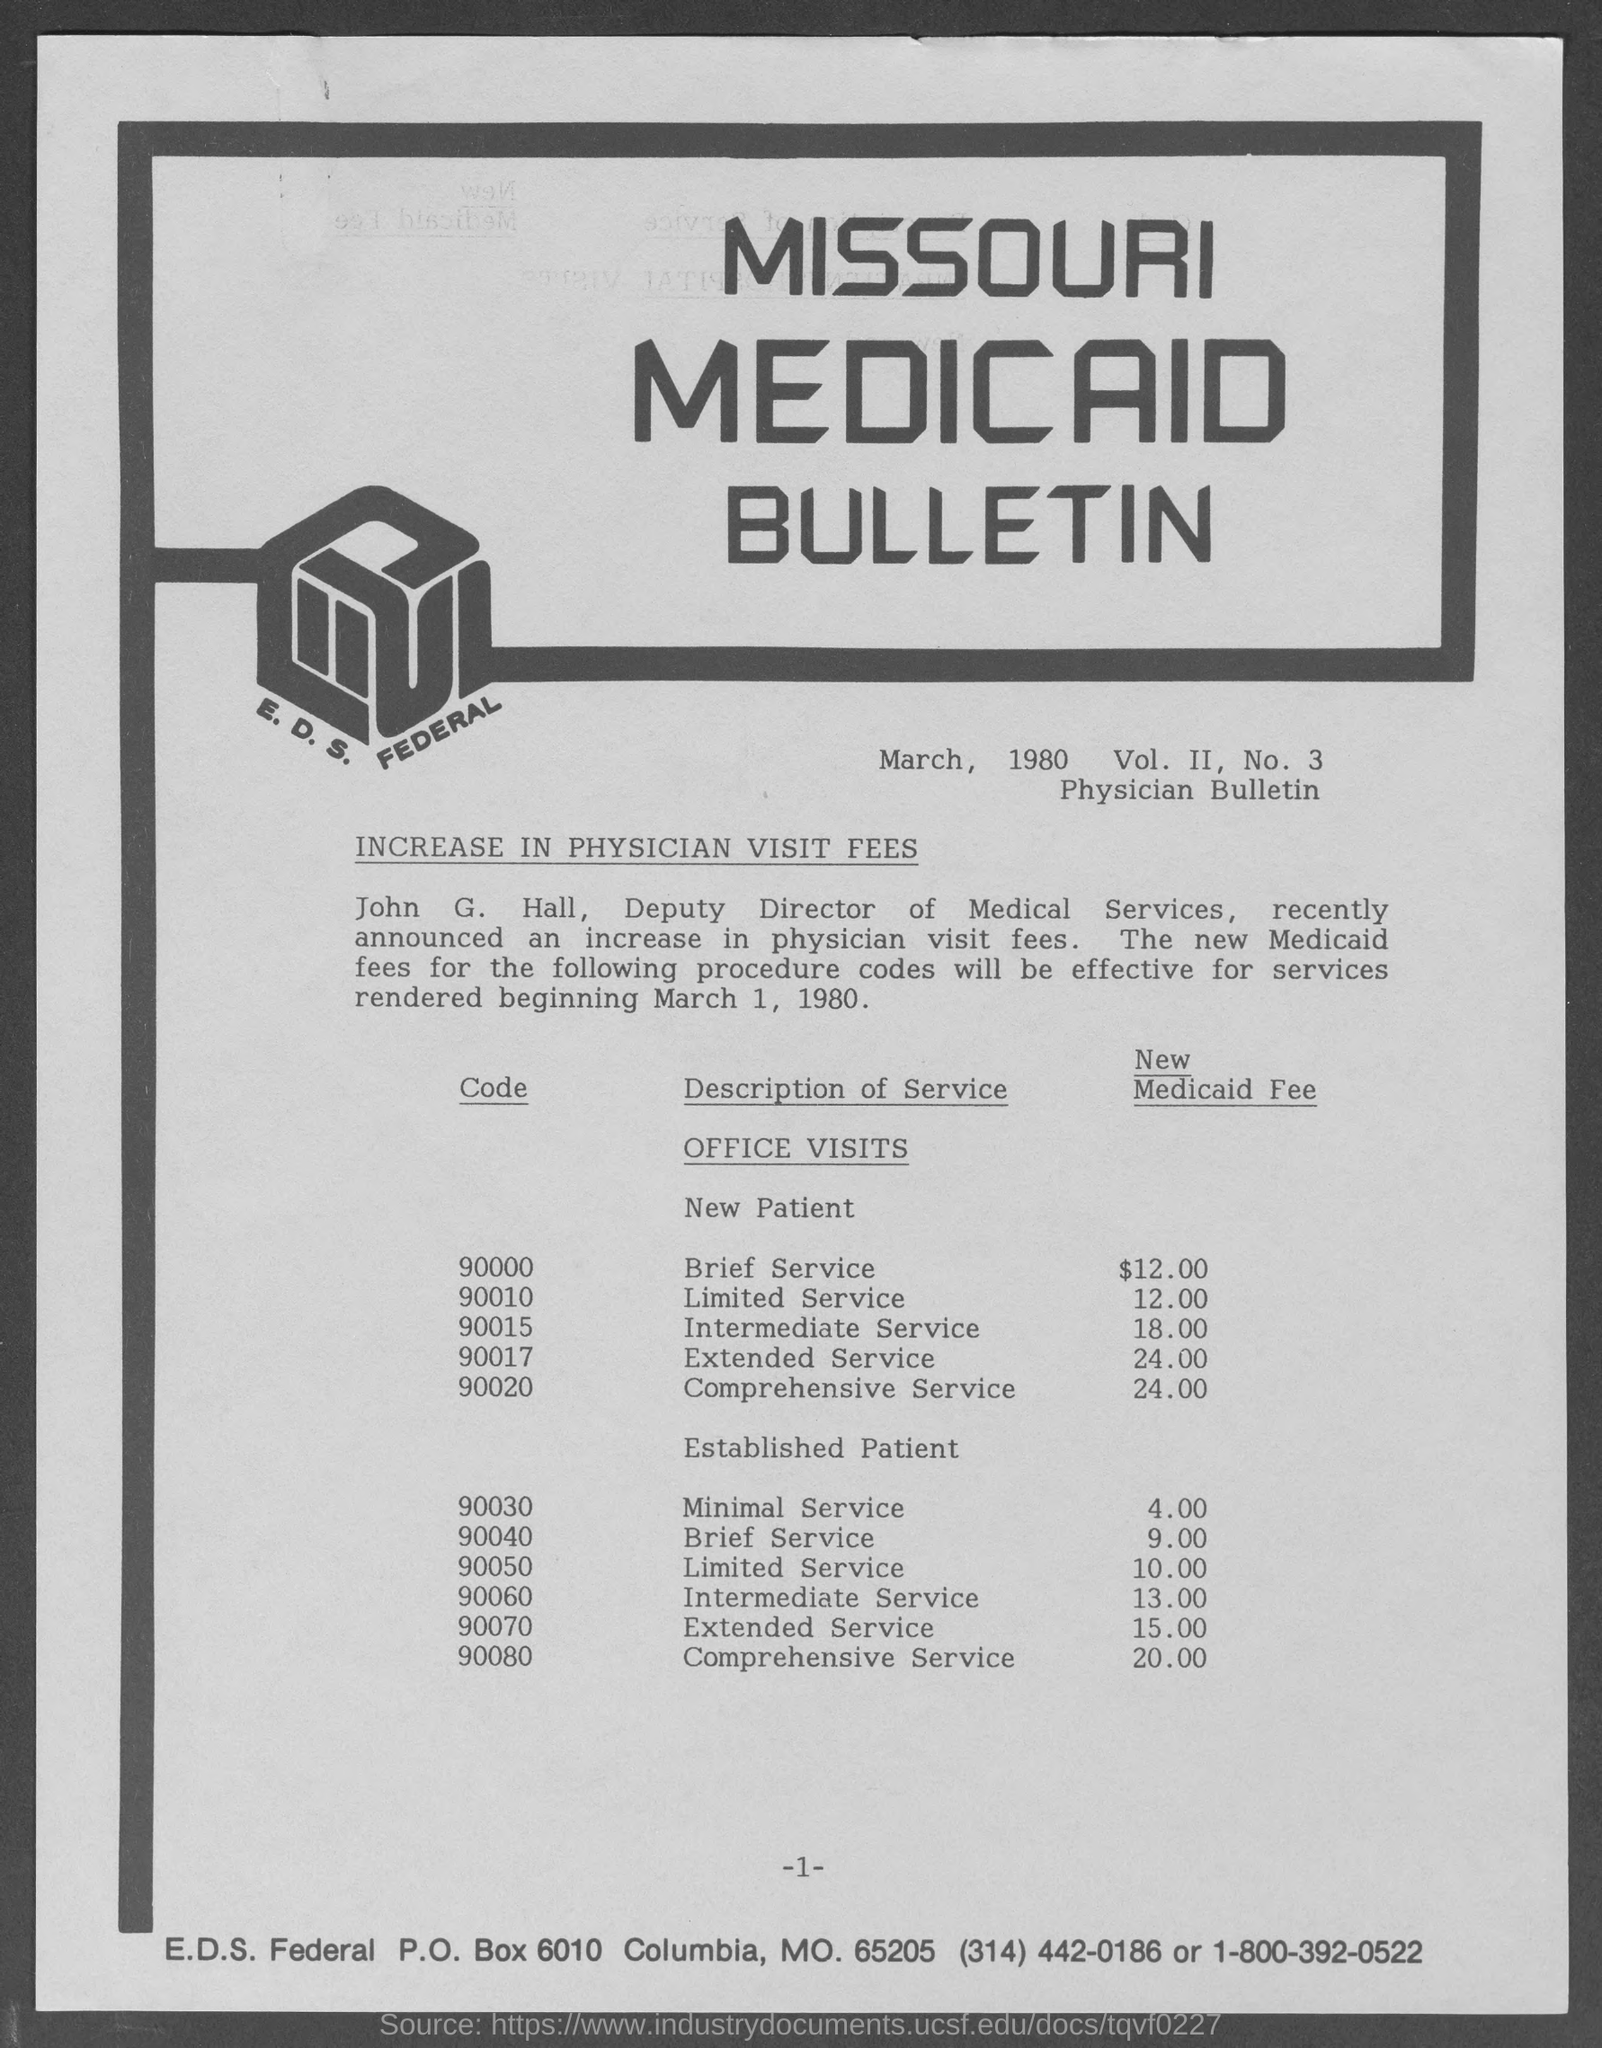Specify some key components in this picture. The new Medicaid fee for an intermediate service performed by an established patient is $13.00. The fee for limited service of a new Medicaid patient is $12.00. The code provided for a brief service for a new patient in the given table is 90000. The fee for intermediate services provided to a new Medicaid patient is $18.00. The current fee for a comprehensive service provided to an established Medicaid patient is $20.00. 